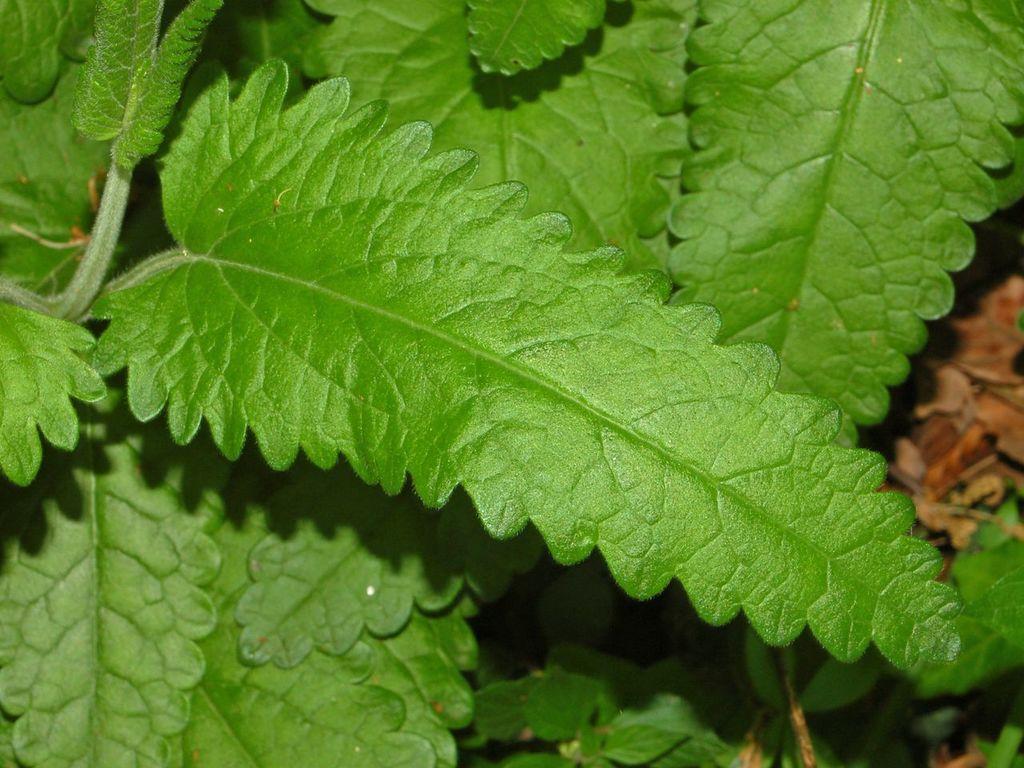Describe this image in one or two sentences. In the foreground of the picture there are leaves and stem. At the bottom of the background there are plants. At the right of the background there are dry leaves, it is blurred. 